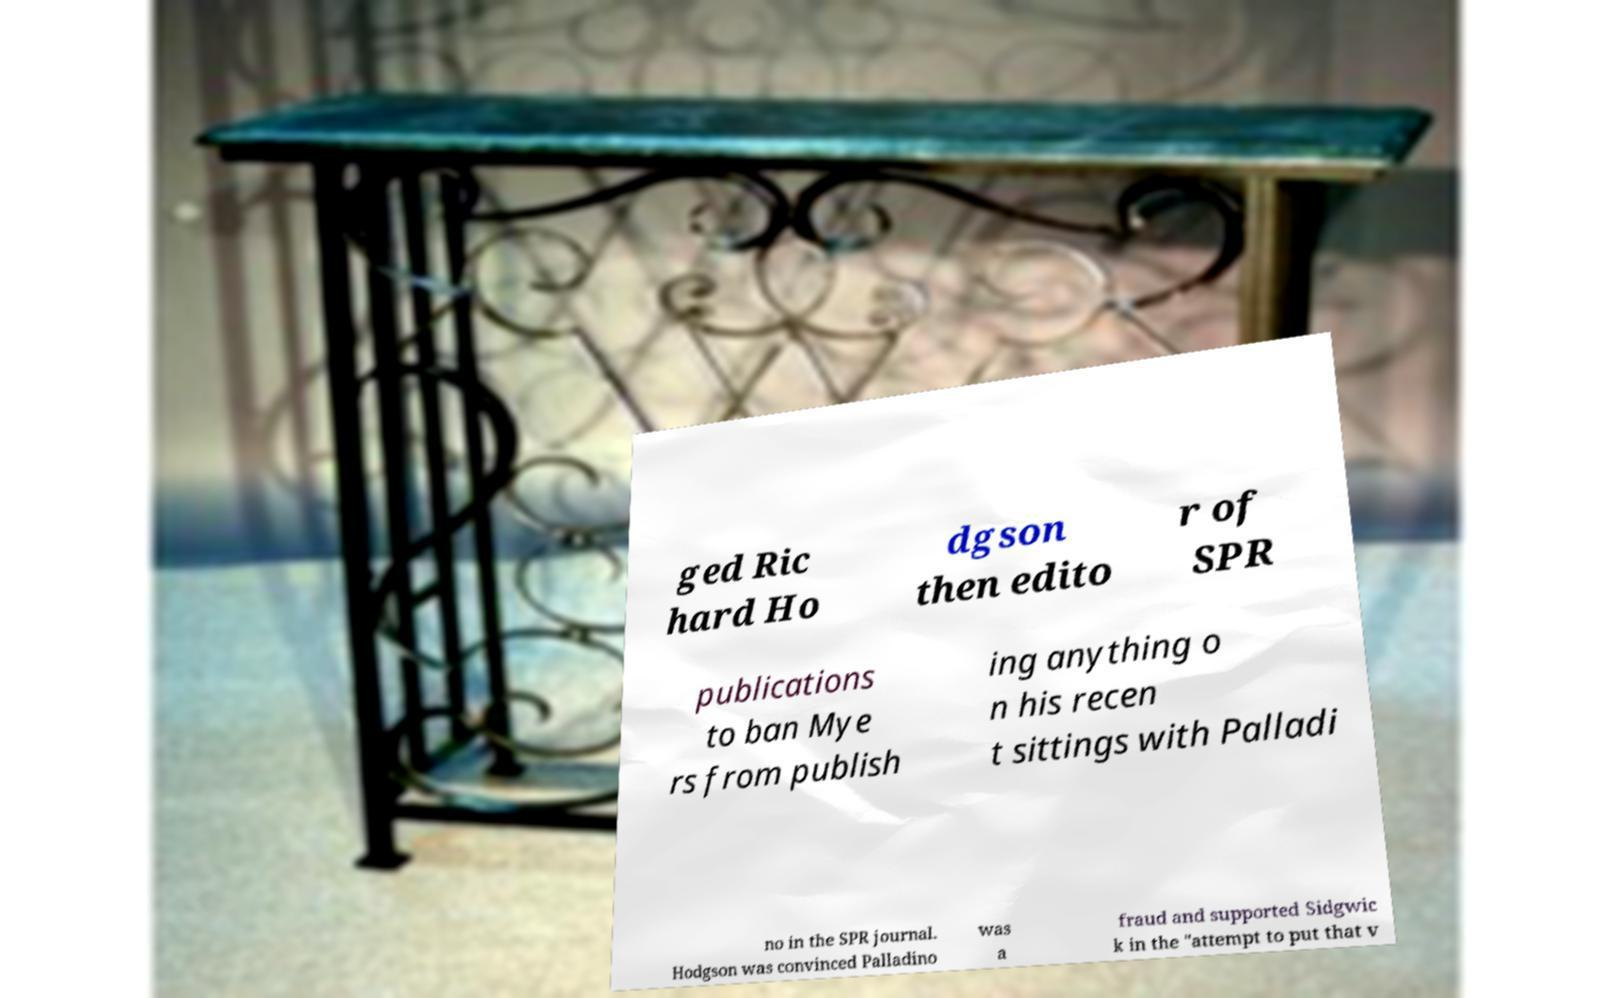Could you assist in decoding the text presented in this image and type it out clearly? ged Ric hard Ho dgson then edito r of SPR publications to ban Mye rs from publish ing anything o n his recen t sittings with Palladi no in the SPR journal. Hodgson was convinced Palladino was a fraud and supported Sidgwic k in the "attempt to put that v 